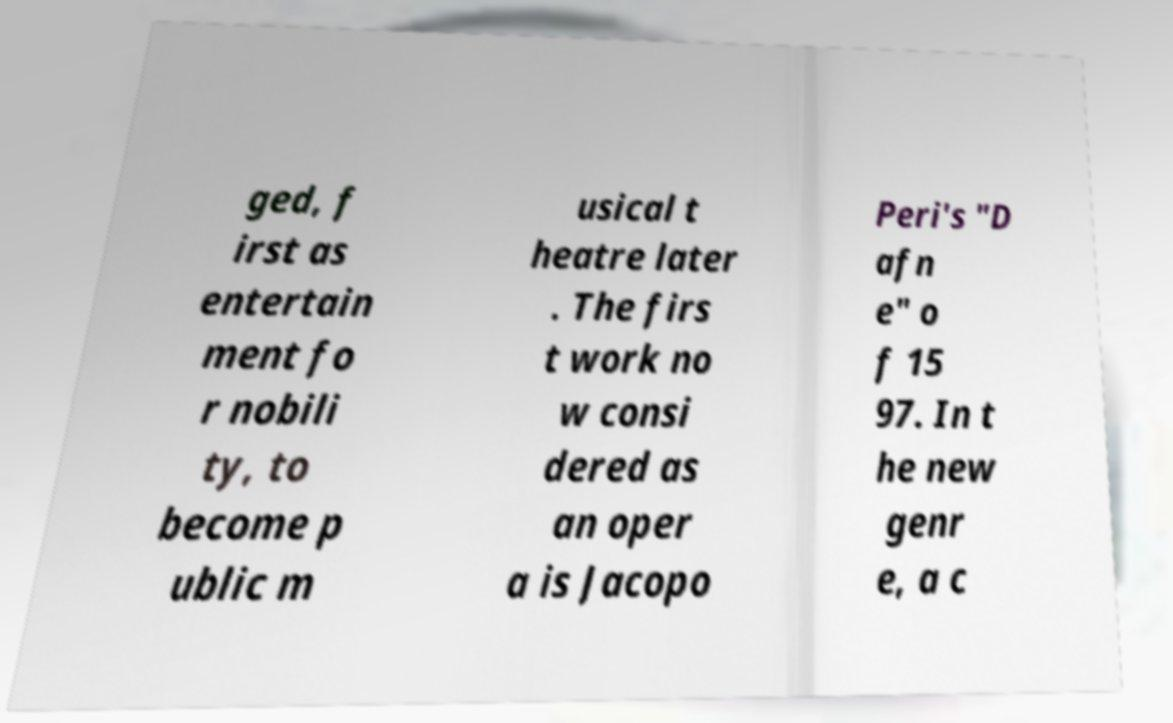Can you accurately transcribe the text from the provided image for me? ged, f irst as entertain ment fo r nobili ty, to become p ublic m usical t heatre later . The firs t work no w consi dered as an oper a is Jacopo Peri's "D afn e" o f 15 97. In t he new genr e, a c 